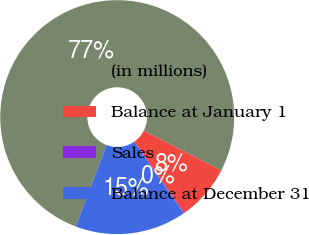Convert chart. <chart><loc_0><loc_0><loc_500><loc_500><pie_chart><fcel>(in millions)<fcel>Balance at January 1<fcel>Sales<fcel>Balance at December 31<nl><fcel>76.76%<fcel>7.75%<fcel>0.08%<fcel>15.41%<nl></chart> 